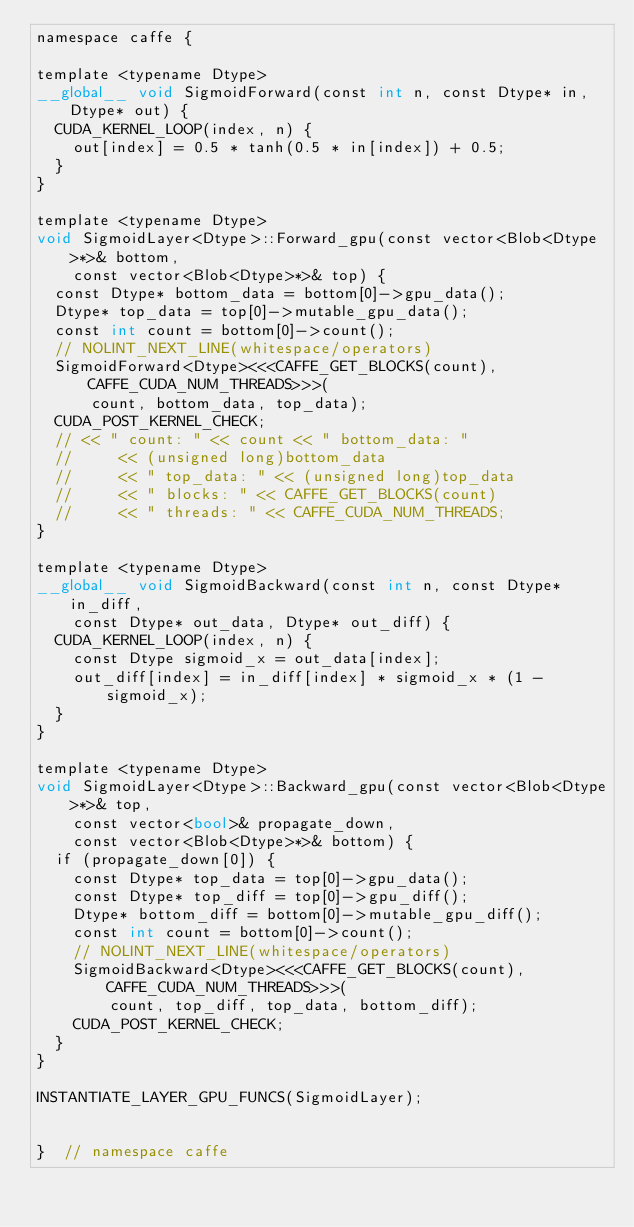<code> <loc_0><loc_0><loc_500><loc_500><_Cuda_>namespace caffe {

template <typename Dtype>
__global__ void SigmoidForward(const int n, const Dtype* in, Dtype* out) {
  CUDA_KERNEL_LOOP(index, n) {
    out[index] = 0.5 * tanh(0.5 * in[index]) + 0.5;
  }
}

template <typename Dtype>
void SigmoidLayer<Dtype>::Forward_gpu(const vector<Blob<Dtype>*>& bottom,
    const vector<Blob<Dtype>*>& top) {
  const Dtype* bottom_data = bottom[0]->gpu_data();
  Dtype* top_data = top[0]->mutable_gpu_data();
  const int count = bottom[0]->count();
  // NOLINT_NEXT_LINE(whitespace/operators)
  SigmoidForward<Dtype><<<CAFFE_GET_BLOCKS(count), CAFFE_CUDA_NUM_THREADS>>>(
      count, bottom_data, top_data);
  CUDA_POST_KERNEL_CHECK;
  // << " count: " << count << " bottom_data: "
  //     << (unsigned long)bottom_data
  //     << " top_data: " << (unsigned long)top_data
  //     << " blocks: " << CAFFE_GET_BLOCKS(count)
  //     << " threads: " << CAFFE_CUDA_NUM_THREADS;
}

template <typename Dtype>
__global__ void SigmoidBackward(const int n, const Dtype* in_diff,
    const Dtype* out_data, Dtype* out_diff) {
  CUDA_KERNEL_LOOP(index, n) {
    const Dtype sigmoid_x = out_data[index];
    out_diff[index] = in_diff[index] * sigmoid_x * (1 - sigmoid_x);
  }
}

template <typename Dtype>
void SigmoidLayer<Dtype>::Backward_gpu(const vector<Blob<Dtype>*>& top,
    const vector<bool>& propagate_down,
    const vector<Blob<Dtype>*>& bottom) {
  if (propagate_down[0]) {
    const Dtype* top_data = top[0]->gpu_data();
    const Dtype* top_diff = top[0]->gpu_diff();
    Dtype* bottom_diff = bottom[0]->mutable_gpu_diff();
    const int count = bottom[0]->count();
    // NOLINT_NEXT_LINE(whitespace/operators)
    SigmoidBackward<Dtype><<<CAFFE_GET_BLOCKS(count), CAFFE_CUDA_NUM_THREADS>>>(
        count, top_diff, top_data, bottom_diff);
    CUDA_POST_KERNEL_CHECK;
  }
}

INSTANTIATE_LAYER_GPU_FUNCS(SigmoidLayer);


}  // namespace caffe
</code> 